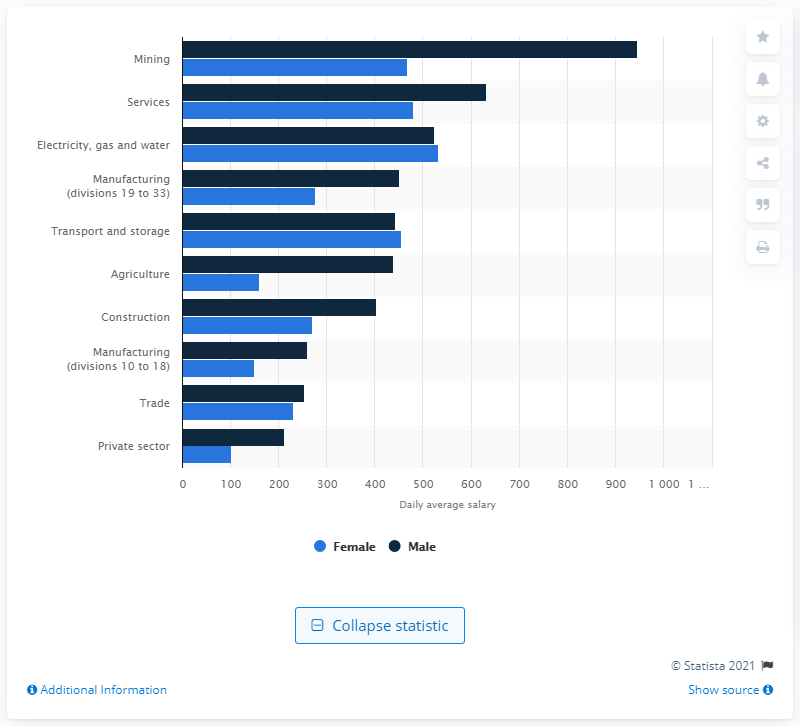List a handful of essential elements in this visual. In 2011-12, the average daily wage for a female worker in the services sector in India was 480.74 rupees. 